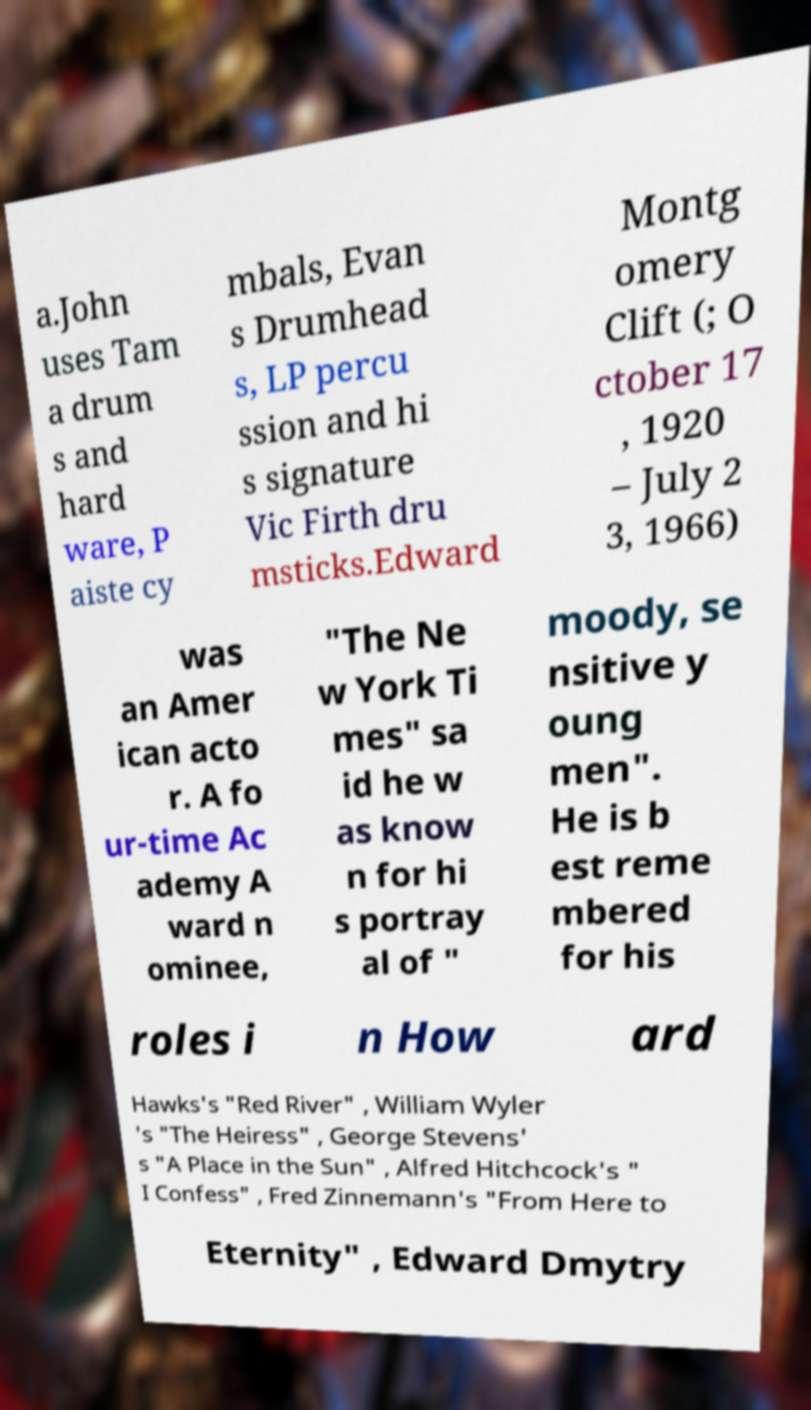Could you extract and type out the text from this image? a.John uses Tam a drum s and hard ware, P aiste cy mbals, Evan s Drumhead s, LP percu ssion and hi s signature Vic Firth dru msticks.Edward Montg omery Clift (; O ctober 17 , 1920 – July 2 3, 1966) was an Amer ican acto r. A fo ur-time Ac ademy A ward n ominee, "The Ne w York Ti mes" sa id he w as know n for hi s portray al of " moody, se nsitive y oung men". He is b est reme mbered for his roles i n How ard Hawks's "Red River" , William Wyler 's "The Heiress" , George Stevens' s "A Place in the Sun" , Alfred Hitchcock's " I Confess" , Fred Zinnemann's "From Here to Eternity" , Edward Dmytry 